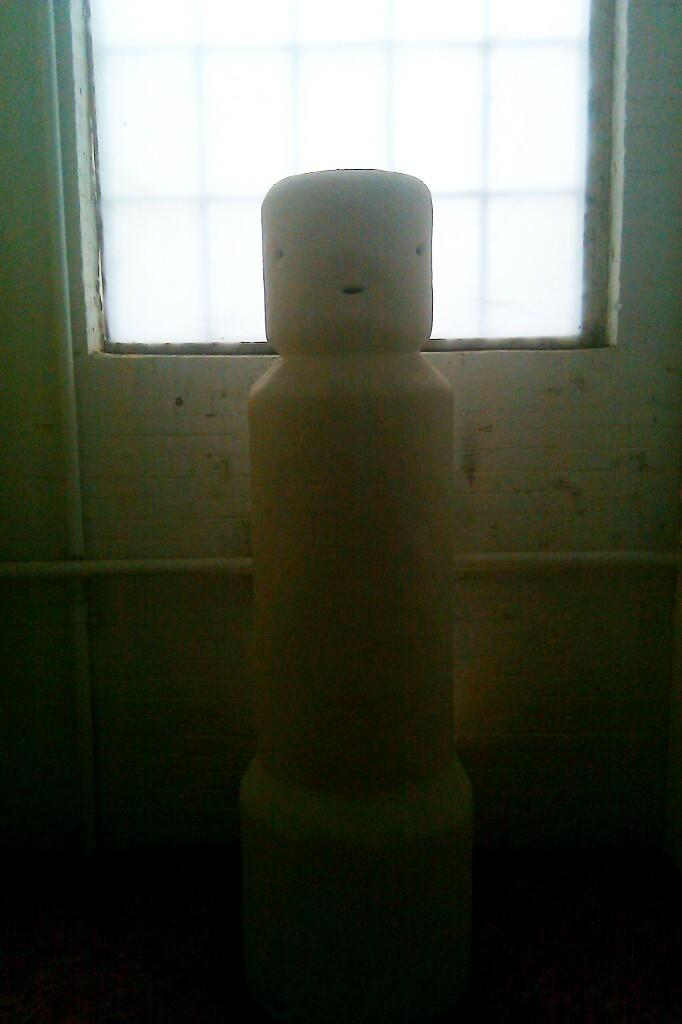What is the main subject of the image? There is a sculpture in the image. What can be seen in the background of the image? There is a wall in the image. Is there any opening in the wall visible in the image? Yes, there is a window in the image. What type of copper material is used to create the quartz sculpture in the image? There is no copper or quartz mentioned in the image, and the sculpture's material is not specified. 